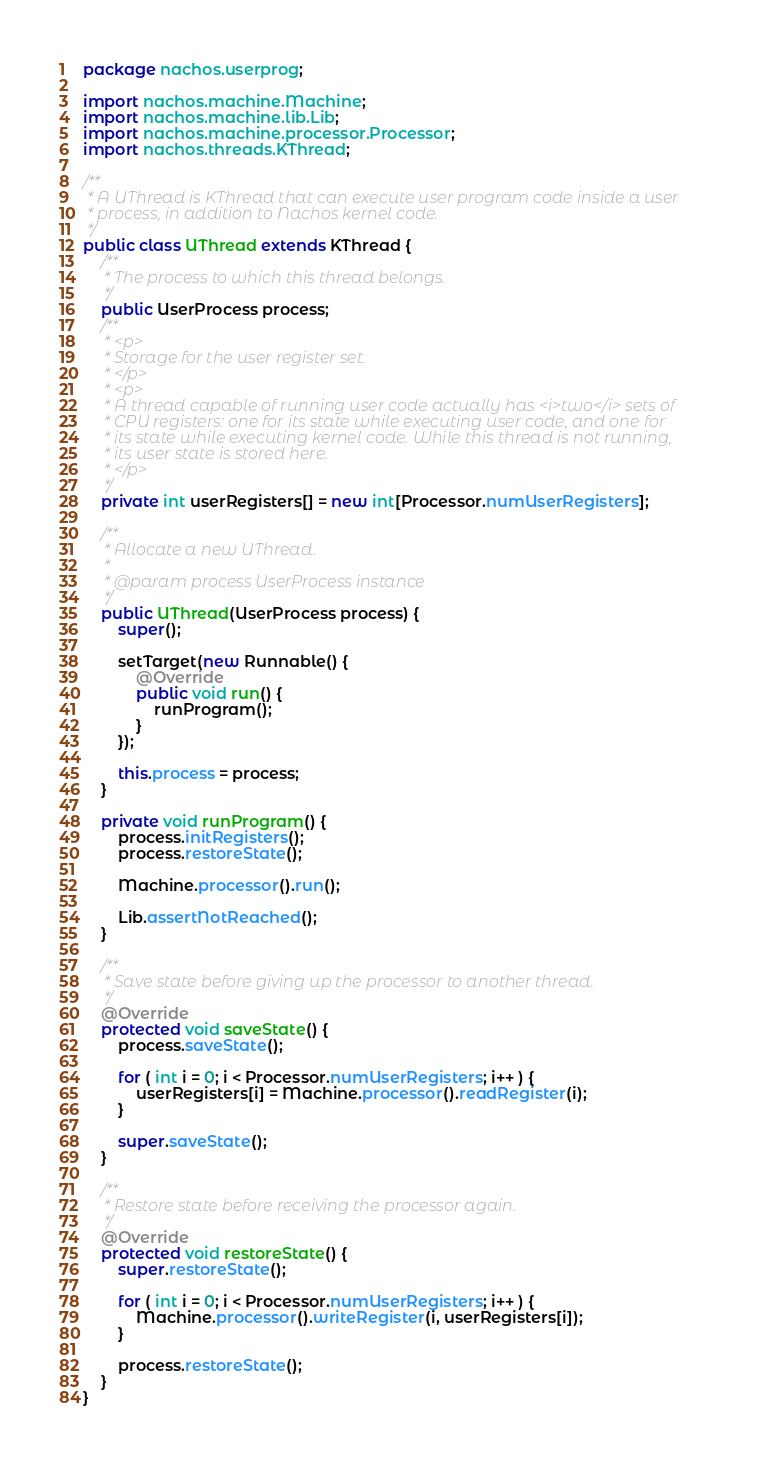<code> <loc_0><loc_0><loc_500><loc_500><_Java_>package nachos.userprog;

import nachos.machine.Machine;
import nachos.machine.lib.Lib;
import nachos.machine.processor.Processor;
import nachos.threads.KThread;

/**
 * A UThread is KThread that can execute user program code inside a user
 * process, in addition to Nachos kernel code.
 */
public class UThread extends KThread {
    /**
     * The process to which this thread belongs.
     */
    public UserProcess process;
    /**
     * <p>
     * Storage for the user register set.
     * </p>
     * <p>
     * A thread capable of running user code actually has <i>two</i> sets of
     * CPU registers: one for its state while executing user code, and one for
     * its state while executing kernel code. While this thread is not running,
     * its user state is stored here.
     * </p>
     */
    private int userRegisters[] = new int[Processor.numUserRegisters];

    /**
     * Allocate a new UThread.
     *
     * @param process UserProcess instance
     */
    public UThread(UserProcess process) {
        super();

        setTarget(new Runnable() {
            @Override
            public void run() {
                runProgram();
            }
        });

        this.process = process;
    }

    private void runProgram() {
        process.initRegisters();
        process.restoreState();

        Machine.processor().run();

        Lib.assertNotReached();
    }

    /**
     * Save state before giving up the processor to another thread.
     */
    @Override
    protected void saveState() {
        process.saveState();

        for ( int i = 0; i < Processor.numUserRegisters; i++ ) {
            userRegisters[i] = Machine.processor().readRegister(i);
        }

        super.saveState();
    }

    /**
     * Restore state before receiving the processor again.
     */
    @Override
    protected void restoreState() {
        super.restoreState();

        for ( int i = 0; i < Processor.numUserRegisters; i++ ) {
            Machine.processor().writeRegister(i, userRegisters[i]);
        }

        process.restoreState();
    }
}
</code> 